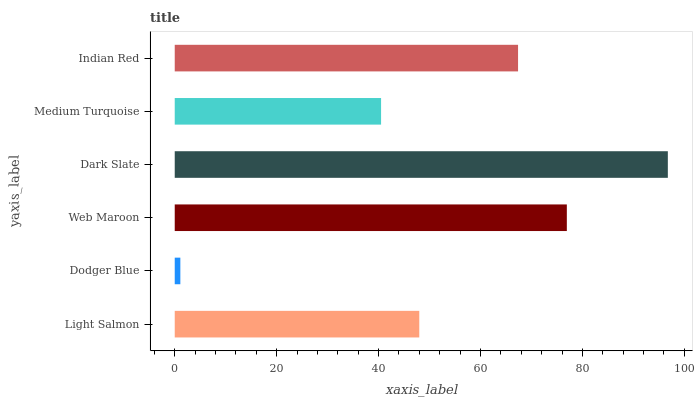Is Dodger Blue the minimum?
Answer yes or no. Yes. Is Dark Slate the maximum?
Answer yes or no. Yes. Is Web Maroon the minimum?
Answer yes or no. No. Is Web Maroon the maximum?
Answer yes or no. No. Is Web Maroon greater than Dodger Blue?
Answer yes or no. Yes. Is Dodger Blue less than Web Maroon?
Answer yes or no. Yes. Is Dodger Blue greater than Web Maroon?
Answer yes or no. No. Is Web Maroon less than Dodger Blue?
Answer yes or no. No. Is Indian Red the high median?
Answer yes or no. Yes. Is Light Salmon the low median?
Answer yes or no. Yes. Is Dark Slate the high median?
Answer yes or no. No. Is Dodger Blue the low median?
Answer yes or no. No. 